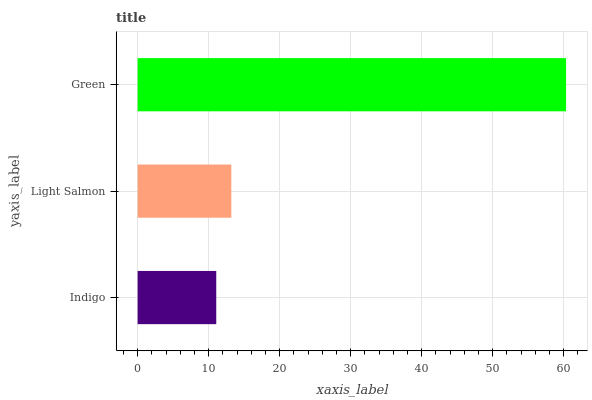Is Indigo the minimum?
Answer yes or no. Yes. Is Green the maximum?
Answer yes or no. Yes. Is Light Salmon the minimum?
Answer yes or no. No. Is Light Salmon the maximum?
Answer yes or no. No. Is Light Salmon greater than Indigo?
Answer yes or no. Yes. Is Indigo less than Light Salmon?
Answer yes or no. Yes. Is Indigo greater than Light Salmon?
Answer yes or no. No. Is Light Salmon less than Indigo?
Answer yes or no. No. Is Light Salmon the high median?
Answer yes or no. Yes. Is Light Salmon the low median?
Answer yes or no. Yes. Is Green the high median?
Answer yes or no. No. Is Green the low median?
Answer yes or no. No. 